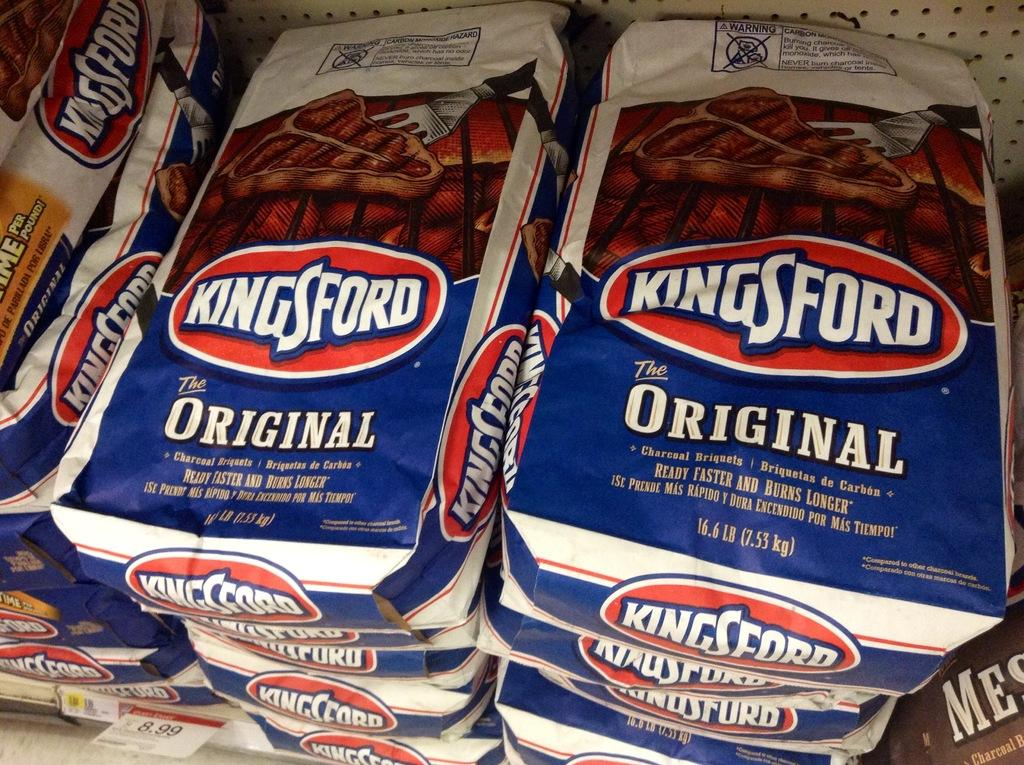What is present in the image that is packaged? There are packets in the image. What is written on the packets? The packets have "kingsford" written on them. What colors are the packets? The packets are white and blue in color. Is there any indication of the price of the packets in the image? Yes, there is a price tag at the bottom of the packets. Can you see an airplane learning to peel an orange in the image? No, there is no airplane or orange present in the image. 